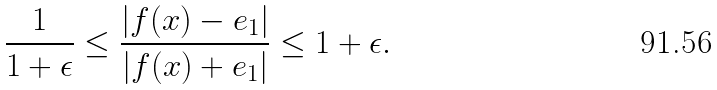Convert formula to latex. <formula><loc_0><loc_0><loc_500><loc_500>\frac { 1 } { 1 + \epsilon } \leq \frac { | f ( x ) - e _ { 1 } | } { | f ( x ) + e _ { 1 } | } \leq 1 + \epsilon .</formula> 